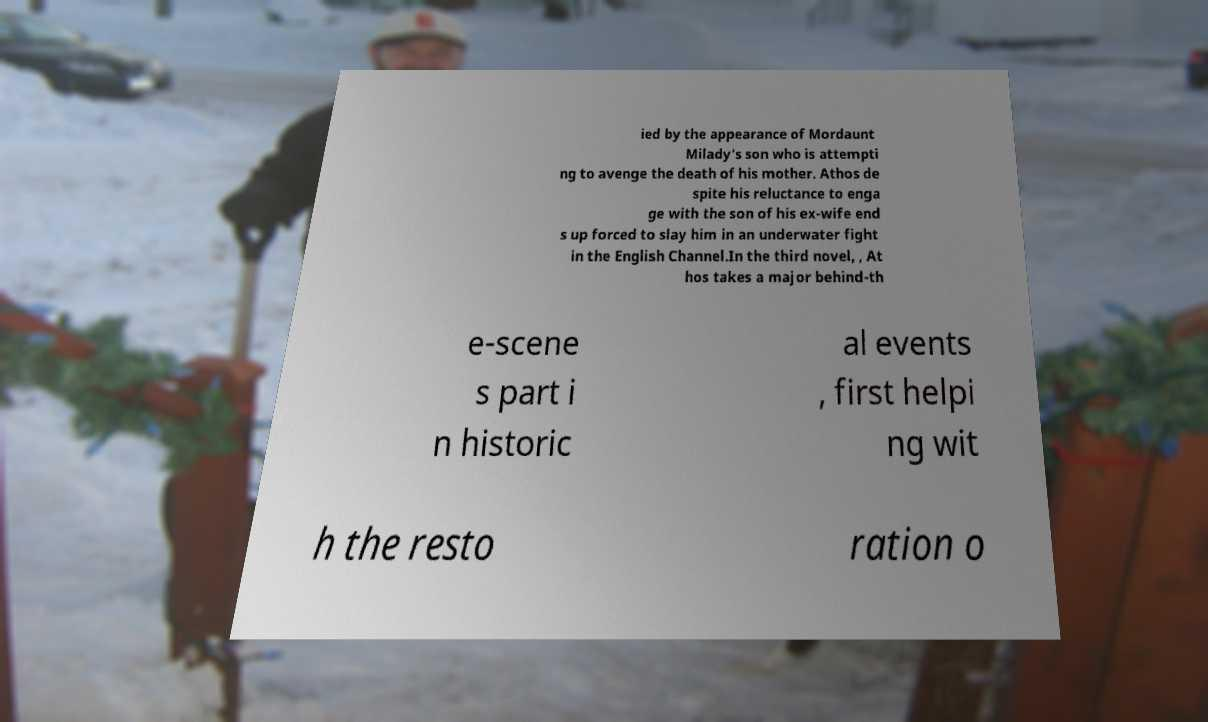Please identify and transcribe the text found in this image. ied by the appearance of Mordaunt Milady's son who is attempti ng to avenge the death of his mother. Athos de spite his reluctance to enga ge with the son of his ex-wife end s up forced to slay him in an underwater fight in the English Channel.In the third novel, , At hos takes a major behind-th e-scene s part i n historic al events , first helpi ng wit h the resto ration o 